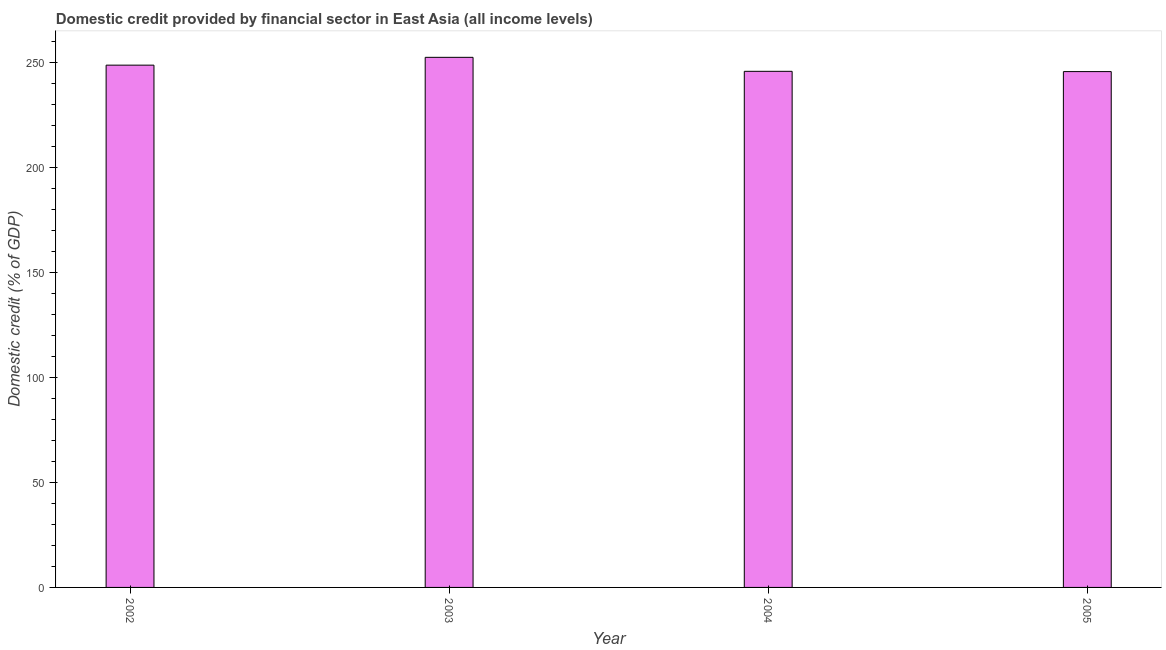What is the title of the graph?
Offer a terse response. Domestic credit provided by financial sector in East Asia (all income levels). What is the label or title of the Y-axis?
Ensure brevity in your answer.  Domestic credit (% of GDP). What is the domestic credit provided by financial sector in 2002?
Make the answer very short. 248.76. Across all years, what is the maximum domestic credit provided by financial sector?
Your response must be concise. 252.49. Across all years, what is the minimum domestic credit provided by financial sector?
Your answer should be very brief. 245.69. In which year was the domestic credit provided by financial sector minimum?
Offer a very short reply. 2005. What is the sum of the domestic credit provided by financial sector?
Keep it short and to the point. 992.77. What is the difference between the domestic credit provided by financial sector in 2004 and 2005?
Provide a short and direct response. 0.13. What is the average domestic credit provided by financial sector per year?
Provide a succinct answer. 248.19. What is the median domestic credit provided by financial sector?
Make the answer very short. 247.29. Do a majority of the years between 2003 and 2004 (inclusive) have domestic credit provided by financial sector greater than 70 %?
Keep it short and to the point. Yes. Is the domestic credit provided by financial sector in 2002 less than that in 2005?
Your answer should be very brief. No. Is the difference between the domestic credit provided by financial sector in 2004 and 2005 greater than the difference between any two years?
Your response must be concise. No. What is the difference between the highest and the second highest domestic credit provided by financial sector?
Make the answer very short. 3.73. Is the sum of the domestic credit provided by financial sector in 2003 and 2005 greater than the maximum domestic credit provided by financial sector across all years?
Keep it short and to the point. Yes. What is the difference between the highest and the lowest domestic credit provided by financial sector?
Your answer should be compact. 6.8. Are all the bars in the graph horizontal?
Make the answer very short. No. How many years are there in the graph?
Your answer should be very brief. 4. What is the difference between two consecutive major ticks on the Y-axis?
Ensure brevity in your answer.  50. What is the Domestic credit (% of GDP) in 2002?
Offer a very short reply. 248.76. What is the Domestic credit (% of GDP) of 2003?
Give a very brief answer. 252.49. What is the Domestic credit (% of GDP) in 2004?
Ensure brevity in your answer.  245.82. What is the Domestic credit (% of GDP) in 2005?
Provide a short and direct response. 245.69. What is the difference between the Domestic credit (% of GDP) in 2002 and 2003?
Offer a very short reply. -3.72. What is the difference between the Domestic credit (% of GDP) in 2002 and 2004?
Provide a short and direct response. 2.94. What is the difference between the Domestic credit (% of GDP) in 2002 and 2005?
Offer a terse response. 3.07. What is the difference between the Domestic credit (% of GDP) in 2003 and 2004?
Your answer should be very brief. 6.67. What is the difference between the Domestic credit (% of GDP) in 2003 and 2005?
Keep it short and to the point. 6.8. What is the difference between the Domestic credit (% of GDP) in 2004 and 2005?
Keep it short and to the point. 0.13. What is the ratio of the Domestic credit (% of GDP) in 2002 to that in 2003?
Offer a terse response. 0.98. What is the ratio of the Domestic credit (% of GDP) in 2003 to that in 2004?
Your answer should be very brief. 1.03. What is the ratio of the Domestic credit (% of GDP) in 2003 to that in 2005?
Offer a very short reply. 1.03. 